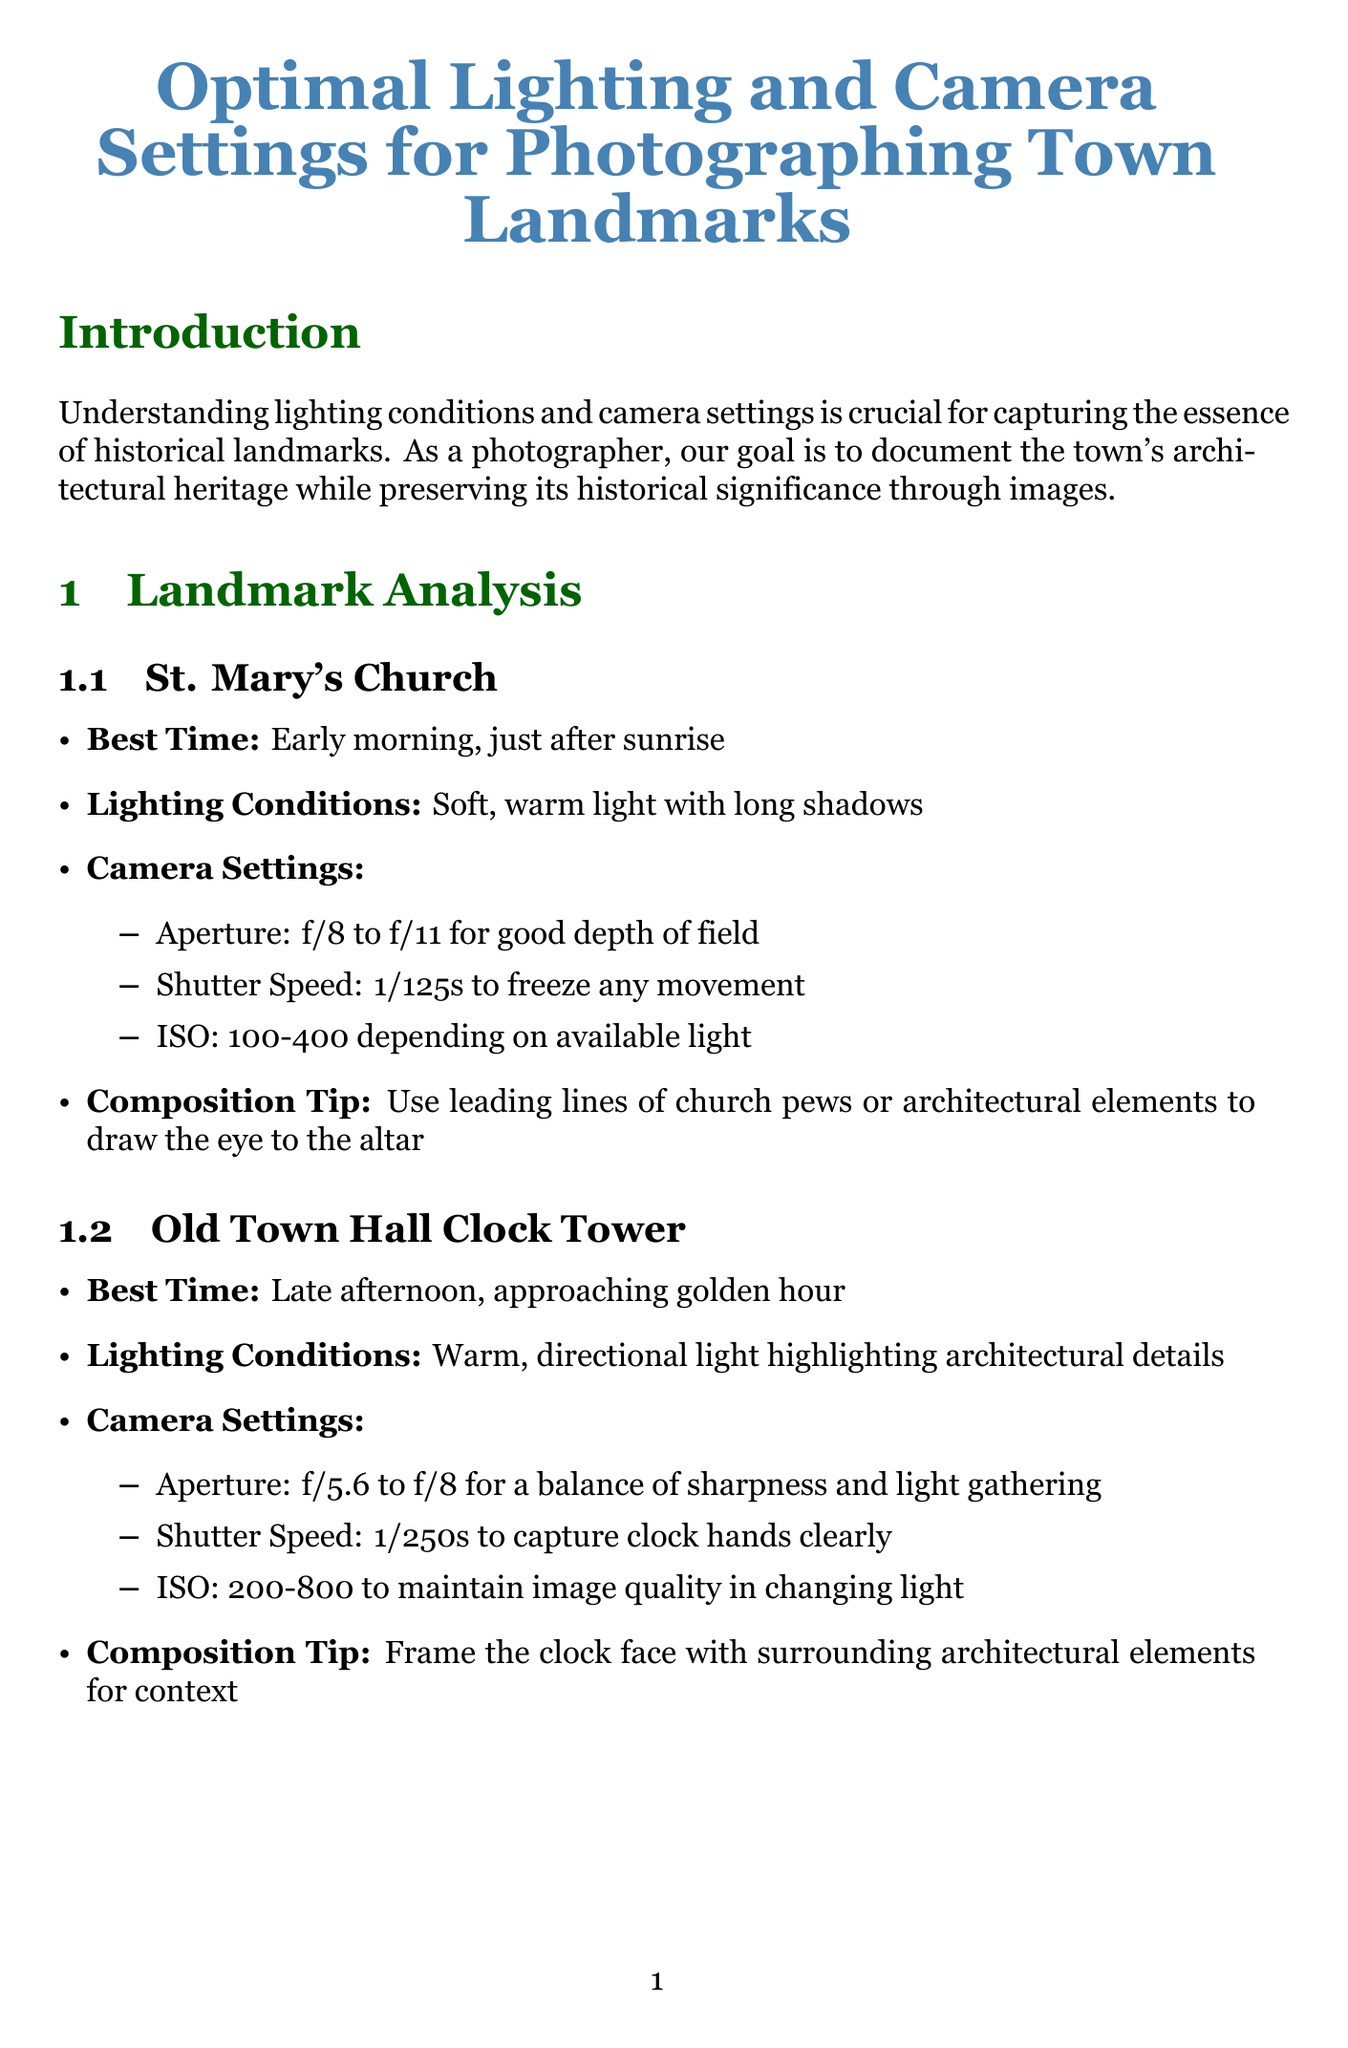What is the best time to photograph St. Mary's Church? The best time is noted in the document for each landmark, specifically for St. Mary's Church, it states early morning, just after sunrise.
Answer: Early morning, just after sunrise What camera setting is recommended for the River Bridge? The document states specific camera settings for each landmark; for River Bridge, these settings include an aperture of f/11 to f/16.
Answer: f/11 to f/16 What type of lens is recommended for capturing expansive views? The document suggests specific equipment recommendations, indicating which items to use for various photography needs, such as a wide-angle lens for expansive architectural views.
Answer: Wide-angle lens What is a key takeaway from the conclusion? The conclusion summarizes the document, highlighting the importance of adapting to lighting conditions and understanding unique features of landmarks to achieve compelling photographs.
Answer: Compelling, historically rich photographs What lighting conditions are ideal for the Old Town Hall Clock Tower? The document provides lighting conditions for each landmark, specifically mentioning warm, directional light for Old Town Hall Clock Tower.
Answer: Warm, directional light highlighting architectural details How long should the shutter speed be for light trails on the River Bridge? The document specifies camera settings for the River Bridge, indicating a shutter speed of 1-4 seconds for capturing light trails from passing cars.
Answer: 1-4 seconds Which ethical consideration is associated with photographing sacred sites? Ethical considerations are outlined regarding respect for private property and religious sensitivities, emphasizing being mindful of cultural sensitivities when photographing sacred sites.
Answer: Cultural sensitivities What is one post-processing tip mentioned in the document? The document lists several post-processing tips, including the use of HDR techniques to balance exposure in high-contrast scenes, which is one of the suggestions provided.
Answer: Use HDR techniques to balance exposure 